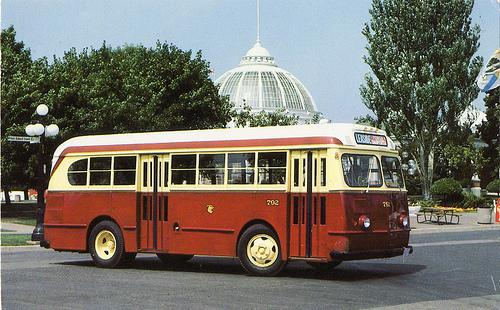Question: what is behind the bus?
Choices:
A. Flowers.
B. Fence.
C. House.
D. Trees.
Answer with the letter. Answer: D Question: who took the picture?
Choices:
A. A reporter.
B. A videographer.
C. The photographer.
D. An amatur.
Answer with the letter. Answer: C 